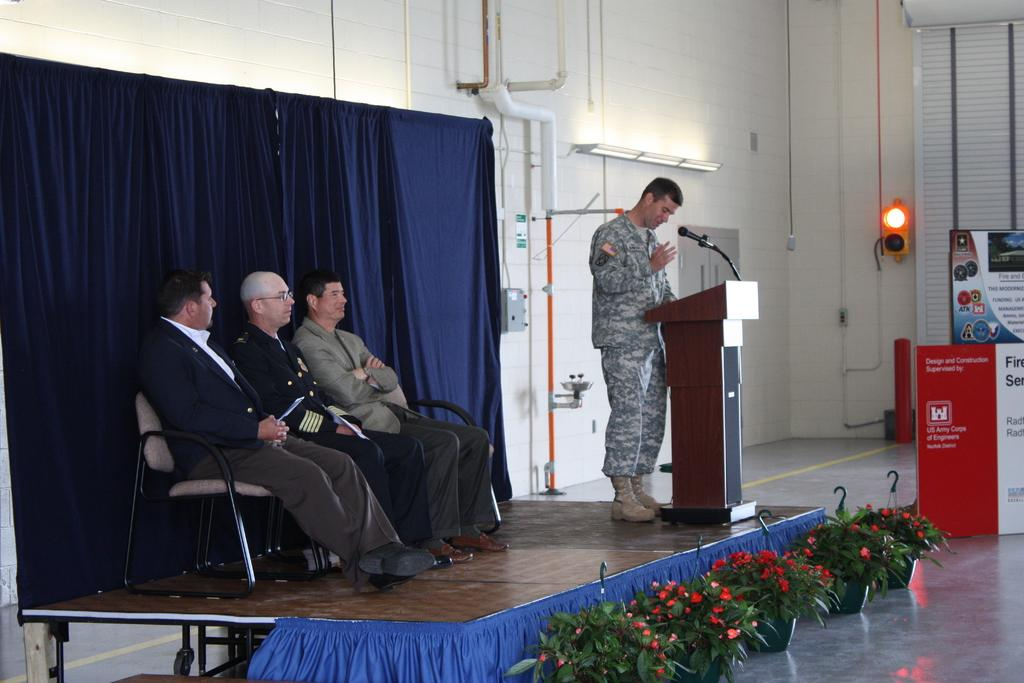How many men are sitting in the image? There are three men sitting on chairs in the image. What is the standing man doing in the image? The standing man is in front of a podium. What can be seen in the background of the image? There is a microphone, a wall, and a pole visible in the background of the image. How many babies are holding a locket in the image? There are no babies or lockets present in the image. 